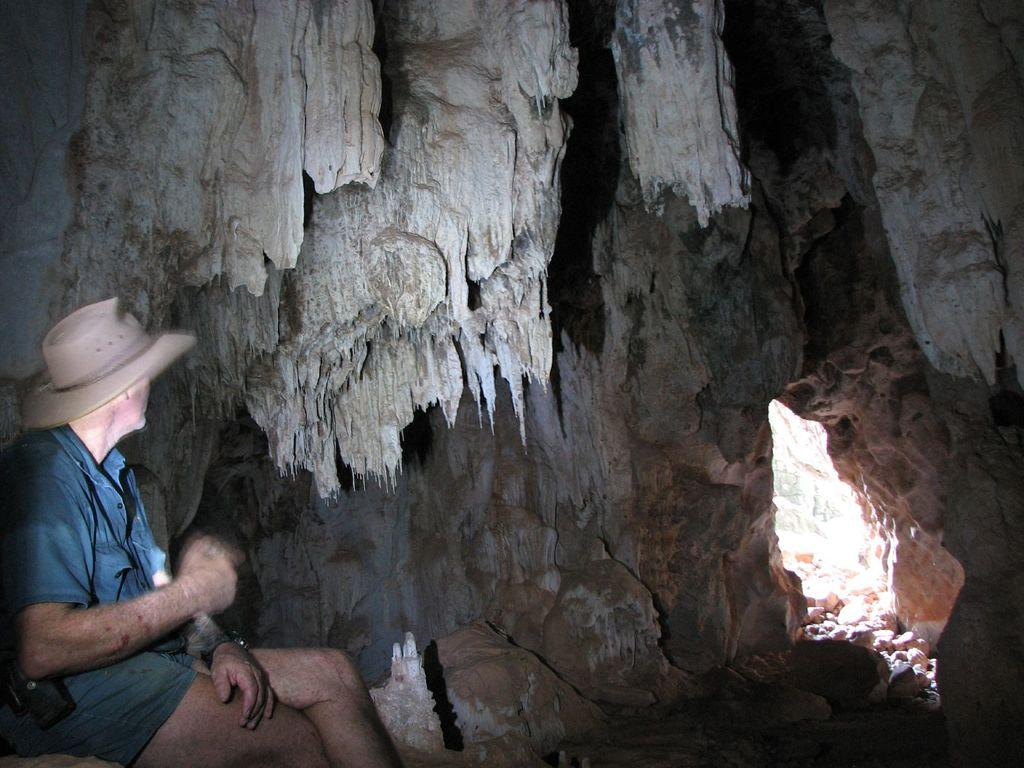What is the main object in the image? There is a cake in the image. Who is present in the image? There is a man in the image. What is the man wearing on his upper body? The man is wearing a shirt. What is the man wearing on his lower body? The man is wearing shorts. What accessory is the man wearing on his wrist? The man is wearing a watch. What headwear is the man wearing? The man is wearing a hat. What type of fish can be seen swimming in the image? There is no fish present in the image. What material is the steel basket made of in the image? There is no steel basket present in the image. 